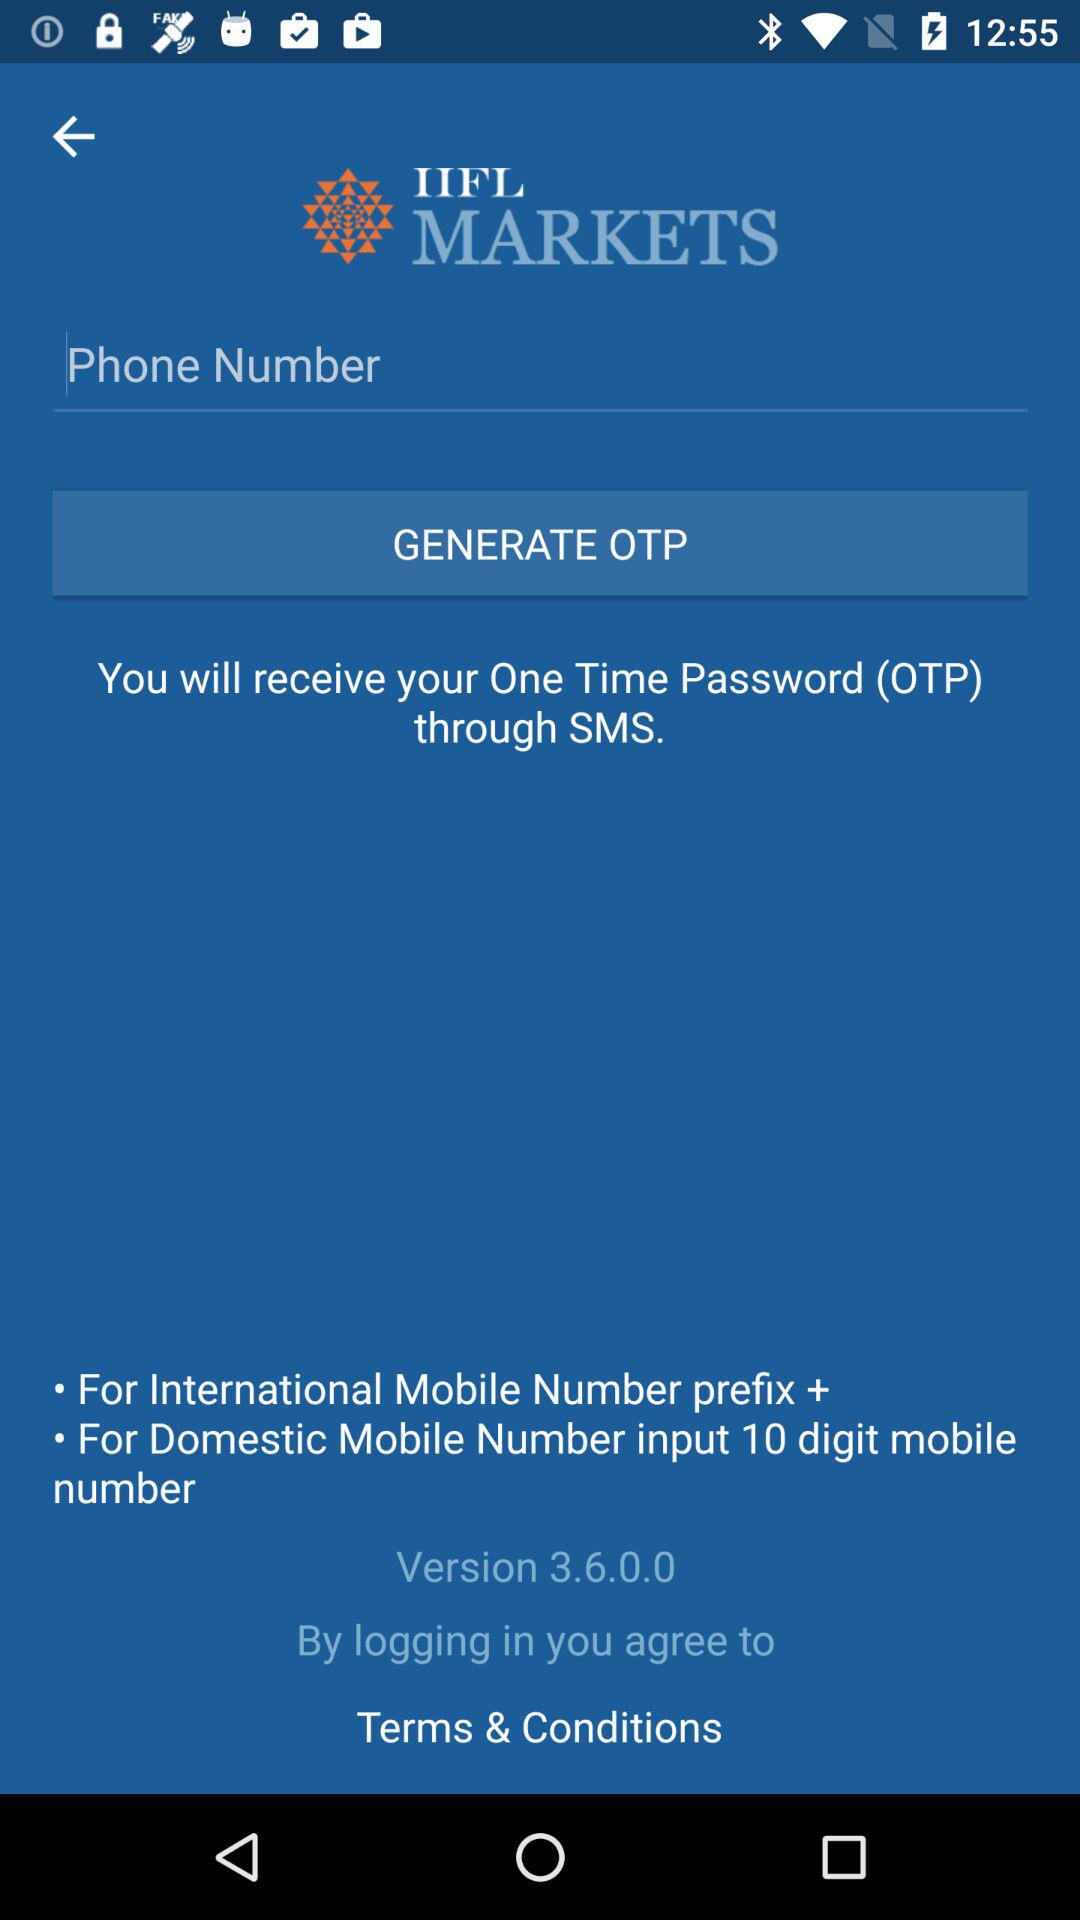How many digits are in the phone number?
Answer the question using a single word or phrase. 10 